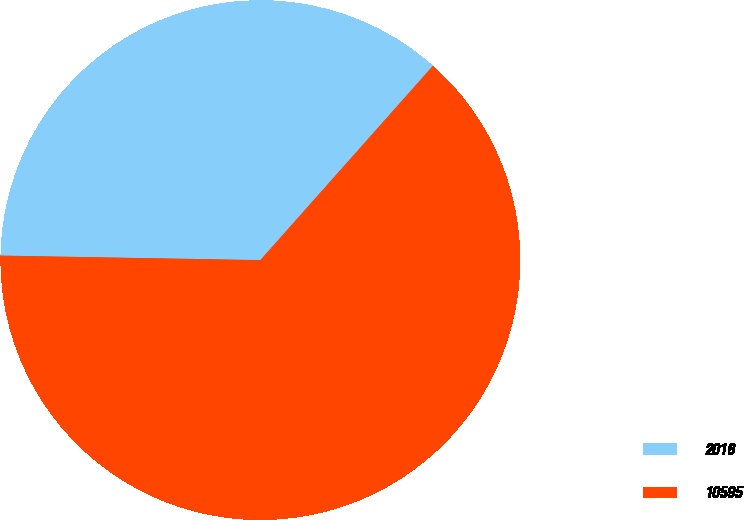Convert chart. <chart><loc_0><loc_0><loc_500><loc_500><pie_chart><fcel>2016<fcel>10595<nl><fcel>36.28%<fcel>63.72%<nl></chart> 